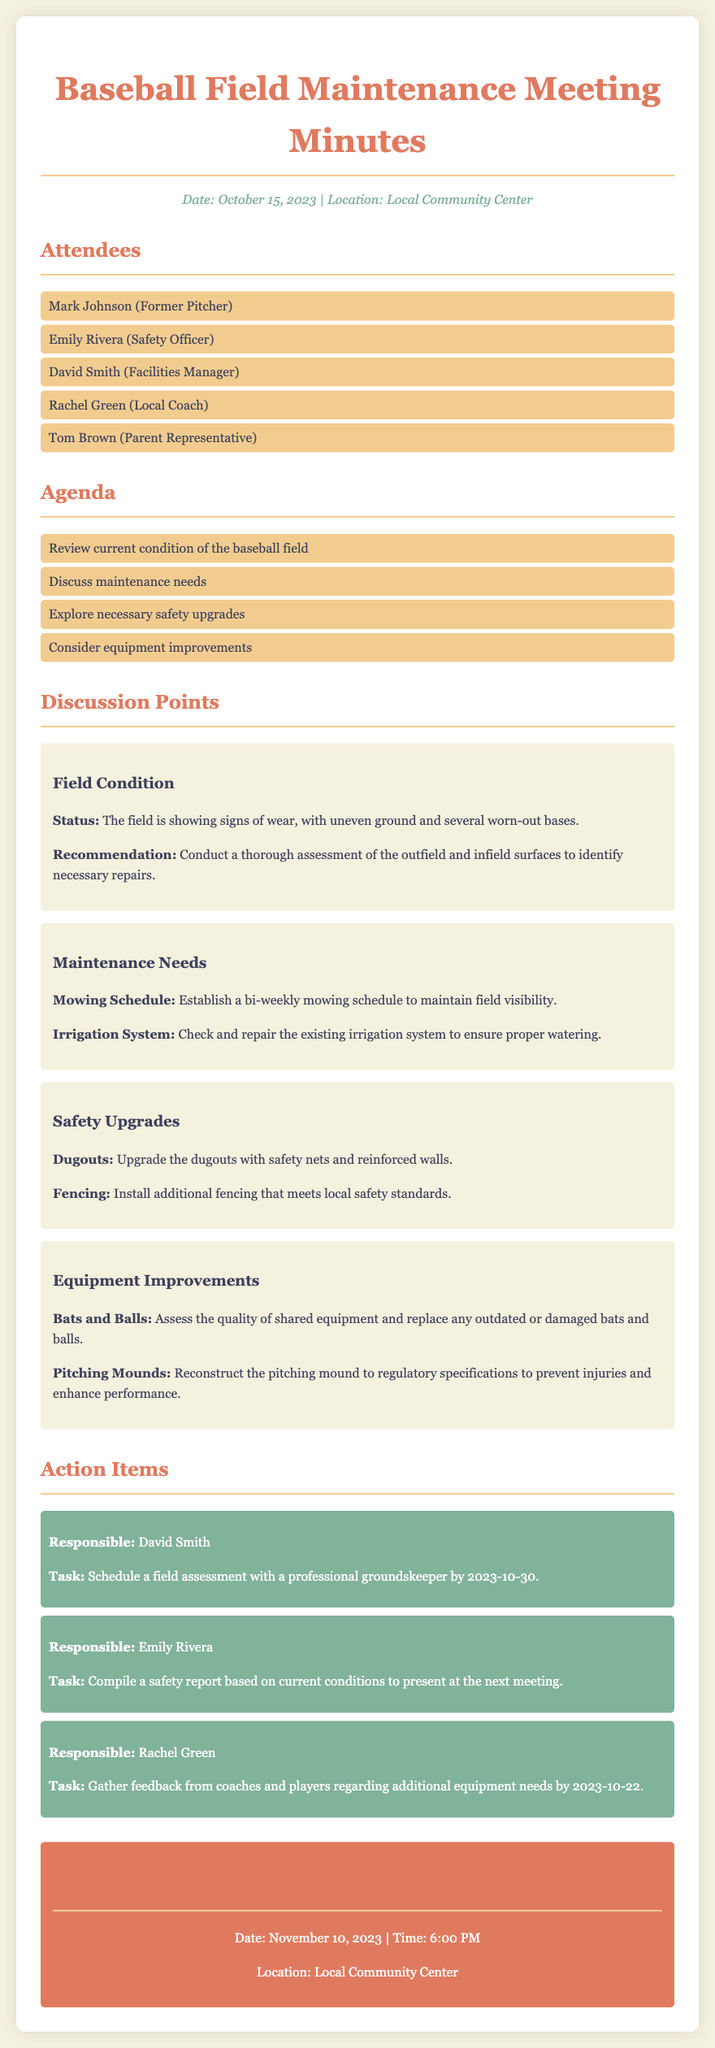What is the date of the meeting? The document states the date of the meeting as October 15, 2023.
Answer: October 15, 2023 Who is responsible for scheduling a field assessment? The document lists David Smith as responsible for scheduling a field assessment with a professional groundskeeper.
Answer: David Smith What safety upgrade is suggested for the dugouts? The minutes recommend upgrading the dugouts with safety nets and reinforced walls.
Answer: Safety nets and reinforced walls When is the next meeting scheduled? According to the document, the next meeting is scheduled for November 10, 2023.
Answer: November 10, 2023 What maintenance task is associated with the irrigation system? The discussion points suggest checking and repairing the existing irrigation system to ensure proper watering.
Answer: Check and repair existing irrigation system How many individuals attended the meeting? By counting the names listed in the attendees' section, the document indicates there are five attendees.
Answer: Five What equipment improvement involves the pitching mound? The minutes mention reconstructing the pitching mound to regulatory specifications to prevent injuries and enhance performance.
Answer: Reconstruct the pitching mound What is the recommended mowing schedule? The minutes state that a bi-weekly mowing schedule should be established to maintain field visibility.
Answer: Bi-weekly Which participant is tasked with compiling a safety report? The document specifies that Emily Rivera is responsible for compiling a safety report based on current conditions.
Answer: Emily Rivera 